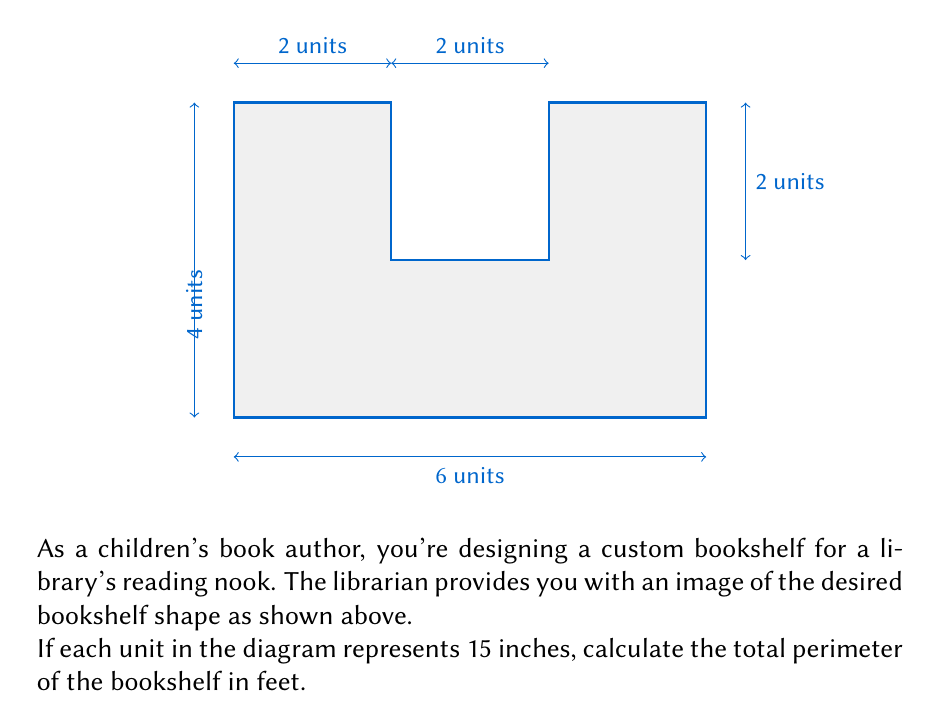Teach me how to tackle this problem. Let's approach this step-by-step:

1) First, we need to count the total units in the perimeter:
   Bottom: 6 units
   Left side: 4 units
   Top: 2 + 2 + 2 = 6 units
   Right side: 4 units
   Total: 6 + 4 + 6 + 4 = 20 units

2) Now, we know that each unit represents 15 inches. So let's convert units to inches:
   $20 \text{ units} \times 15 \text{ inches/unit} = 300 \text{ inches}$

3) The question asks for the answer in feet, so we need to convert inches to feet:
   $300 \text{ inches} \div 12 \text{ inches/foot} = 25 \text{ feet}$

Therefore, the total perimeter of the bookshelf is 25 feet.
Answer: 25 feet 